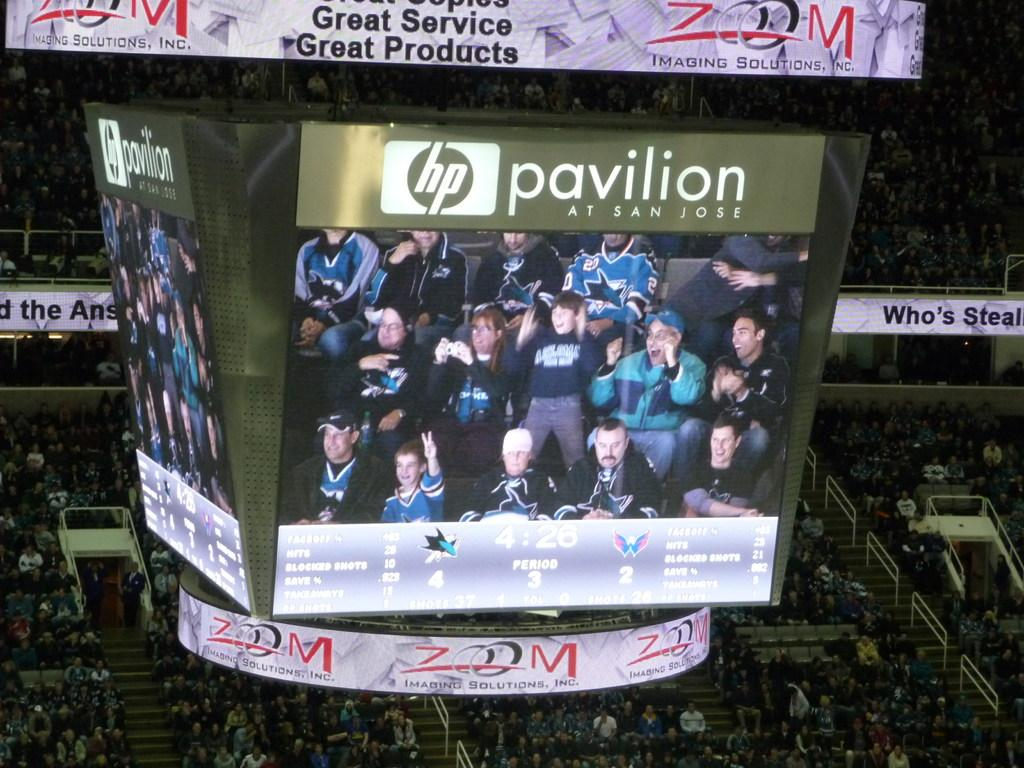<image>
Write a terse but informative summary of the picture. A megatron above an arena that says it's the hp pavilion at San Jose. 